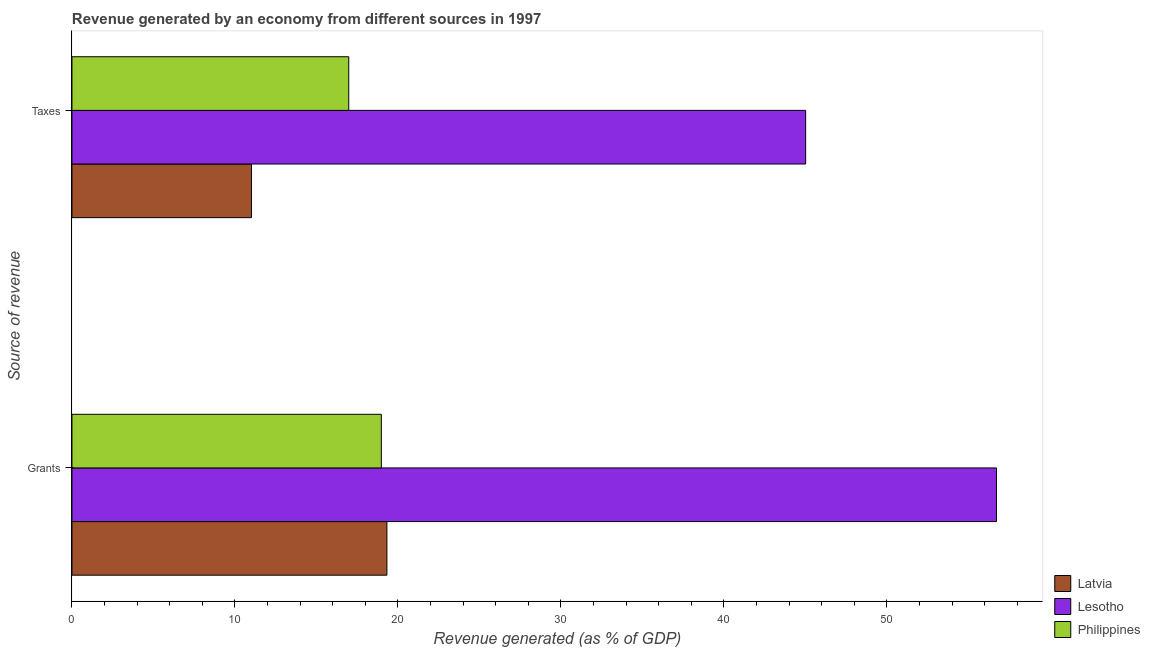How many different coloured bars are there?
Make the answer very short. 3. How many groups of bars are there?
Keep it short and to the point. 2. How many bars are there on the 2nd tick from the top?
Provide a succinct answer. 3. How many bars are there on the 1st tick from the bottom?
Provide a succinct answer. 3. What is the label of the 1st group of bars from the top?
Make the answer very short. Taxes. What is the revenue generated by grants in Latvia?
Offer a very short reply. 19.33. Across all countries, what is the maximum revenue generated by grants?
Offer a very short reply. 56.73. Across all countries, what is the minimum revenue generated by grants?
Offer a very short reply. 18.98. In which country was the revenue generated by grants maximum?
Ensure brevity in your answer.  Lesotho. In which country was the revenue generated by taxes minimum?
Provide a succinct answer. Latvia. What is the total revenue generated by taxes in the graph?
Make the answer very short. 73.02. What is the difference between the revenue generated by taxes in Latvia and that in Philippines?
Your response must be concise. -5.97. What is the difference between the revenue generated by taxes in Latvia and the revenue generated by grants in Philippines?
Provide a short and direct response. -7.97. What is the average revenue generated by taxes per country?
Your response must be concise. 24.34. What is the difference between the revenue generated by taxes and revenue generated by grants in Philippines?
Provide a succinct answer. -2. What is the ratio of the revenue generated by grants in Latvia to that in Philippines?
Give a very brief answer. 1.02. In how many countries, is the revenue generated by grants greater than the average revenue generated by grants taken over all countries?
Provide a succinct answer. 1. What does the 2nd bar from the top in Taxes represents?
Your answer should be very brief. Lesotho. What does the 1st bar from the bottom in Taxes represents?
Ensure brevity in your answer.  Latvia. What is the difference between two consecutive major ticks on the X-axis?
Your answer should be compact. 10. Does the graph contain any zero values?
Your response must be concise. No. How many legend labels are there?
Offer a very short reply. 3. What is the title of the graph?
Provide a succinct answer. Revenue generated by an economy from different sources in 1997. What is the label or title of the X-axis?
Your answer should be very brief. Revenue generated (as % of GDP). What is the label or title of the Y-axis?
Your answer should be very brief. Source of revenue. What is the Revenue generated (as % of GDP) of Latvia in Grants?
Your answer should be very brief. 19.33. What is the Revenue generated (as % of GDP) of Lesotho in Grants?
Your answer should be compact. 56.73. What is the Revenue generated (as % of GDP) of Philippines in Grants?
Offer a very short reply. 18.98. What is the Revenue generated (as % of GDP) of Latvia in Taxes?
Ensure brevity in your answer.  11.02. What is the Revenue generated (as % of GDP) of Lesotho in Taxes?
Your answer should be very brief. 45.02. What is the Revenue generated (as % of GDP) in Philippines in Taxes?
Keep it short and to the point. 16.98. Across all Source of revenue, what is the maximum Revenue generated (as % of GDP) of Latvia?
Your answer should be compact. 19.33. Across all Source of revenue, what is the maximum Revenue generated (as % of GDP) of Lesotho?
Make the answer very short. 56.73. Across all Source of revenue, what is the maximum Revenue generated (as % of GDP) of Philippines?
Your answer should be very brief. 18.98. Across all Source of revenue, what is the minimum Revenue generated (as % of GDP) of Latvia?
Keep it short and to the point. 11.02. Across all Source of revenue, what is the minimum Revenue generated (as % of GDP) of Lesotho?
Offer a very short reply. 45.02. Across all Source of revenue, what is the minimum Revenue generated (as % of GDP) in Philippines?
Your response must be concise. 16.98. What is the total Revenue generated (as % of GDP) of Latvia in the graph?
Provide a short and direct response. 30.34. What is the total Revenue generated (as % of GDP) in Lesotho in the graph?
Your answer should be very brief. 101.75. What is the total Revenue generated (as % of GDP) of Philippines in the graph?
Your answer should be compact. 35.97. What is the difference between the Revenue generated (as % of GDP) of Latvia in Grants and that in Taxes?
Offer a very short reply. 8.31. What is the difference between the Revenue generated (as % of GDP) of Lesotho in Grants and that in Taxes?
Your response must be concise. 11.71. What is the difference between the Revenue generated (as % of GDP) of Philippines in Grants and that in Taxes?
Provide a short and direct response. 2. What is the difference between the Revenue generated (as % of GDP) of Latvia in Grants and the Revenue generated (as % of GDP) of Lesotho in Taxes?
Give a very brief answer. -25.69. What is the difference between the Revenue generated (as % of GDP) of Latvia in Grants and the Revenue generated (as % of GDP) of Philippines in Taxes?
Ensure brevity in your answer.  2.34. What is the difference between the Revenue generated (as % of GDP) in Lesotho in Grants and the Revenue generated (as % of GDP) in Philippines in Taxes?
Your response must be concise. 39.75. What is the average Revenue generated (as % of GDP) in Latvia per Source of revenue?
Provide a succinct answer. 15.17. What is the average Revenue generated (as % of GDP) in Lesotho per Source of revenue?
Make the answer very short. 50.88. What is the average Revenue generated (as % of GDP) of Philippines per Source of revenue?
Your response must be concise. 17.98. What is the difference between the Revenue generated (as % of GDP) in Latvia and Revenue generated (as % of GDP) in Lesotho in Grants?
Your answer should be very brief. -37.41. What is the difference between the Revenue generated (as % of GDP) of Latvia and Revenue generated (as % of GDP) of Philippines in Grants?
Give a very brief answer. 0.34. What is the difference between the Revenue generated (as % of GDP) of Lesotho and Revenue generated (as % of GDP) of Philippines in Grants?
Provide a succinct answer. 37.75. What is the difference between the Revenue generated (as % of GDP) of Latvia and Revenue generated (as % of GDP) of Lesotho in Taxes?
Your response must be concise. -34.01. What is the difference between the Revenue generated (as % of GDP) in Latvia and Revenue generated (as % of GDP) in Philippines in Taxes?
Make the answer very short. -5.97. What is the difference between the Revenue generated (as % of GDP) of Lesotho and Revenue generated (as % of GDP) of Philippines in Taxes?
Make the answer very short. 28.04. What is the ratio of the Revenue generated (as % of GDP) of Latvia in Grants to that in Taxes?
Provide a short and direct response. 1.75. What is the ratio of the Revenue generated (as % of GDP) of Lesotho in Grants to that in Taxes?
Your answer should be very brief. 1.26. What is the ratio of the Revenue generated (as % of GDP) in Philippines in Grants to that in Taxes?
Your response must be concise. 1.12. What is the difference between the highest and the second highest Revenue generated (as % of GDP) of Latvia?
Your answer should be compact. 8.31. What is the difference between the highest and the second highest Revenue generated (as % of GDP) of Lesotho?
Make the answer very short. 11.71. What is the difference between the highest and the second highest Revenue generated (as % of GDP) of Philippines?
Keep it short and to the point. 2. What is the difference between the highest and the lowest Revenue generated (as % of GDP) in Latvia?
Make the answer very short. 8.31. What is the difference between the highest and the lowest Revenue generated (as % of GDP) in Lesotho?
Offer a terse response. 11.71. What is the difference between the highest and the lowest Revenue generated (as % of GDP) of Philippines?
Offer a very short reply. 2. 